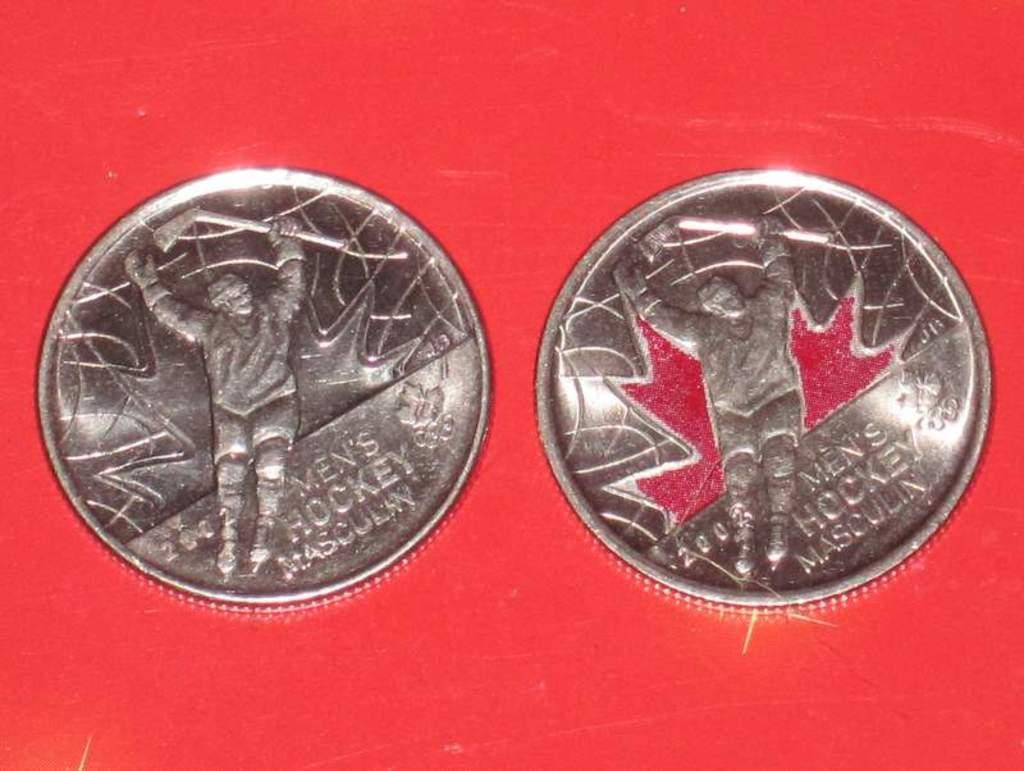Provide a one-sentence caption for the provided image. Two  coins with  the inscription Men's hockey on them. 